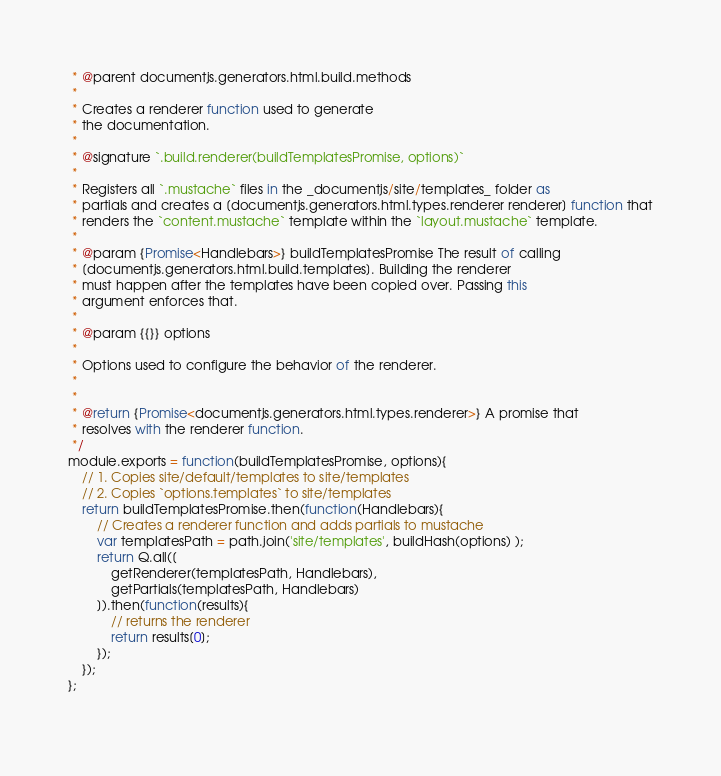<code> <loc_0><loc_0><loc_500><loc_500><_JavaScript_> * @parent documentjs.generators.html.build.methods
 * 
 * Creates a renderer function used to generate
 * the documentation.
 * 
 * @signature `.build.renderer(buildTemplatesPromise, options)`
 * 
 * Registers all `.mustache` files in the _documentjs/site/templates_ folder as 
 * partials and creates a [documentjs.generators.html.types.renderer renderer] function that
 * renders the `content.mustache` template within the `layout.mustache` template. 
 * 
 * @param {Promise<Handlebars>} buildTemplatesPromise The result of calling 
 * [documentjs.generators.html.build.templates]. Building the renderer
 * must happen after the templates have been copied over. Passing this 
 * argument enforces that.
 * 
 * @param {{}} options
 * 
 * Options used to configure the behavior of the renderer.
 * 
 * 
 * @return {Promise<documentjs.generators.html.types.renderer>} A promise that
 * resolves with the renderer function.
 */
module.exports = function(buildTemplatesPromise, options){
	// 1. Copies site/default/templates to site/templates
	// 2. Copies `options.templates` to site/templates
	return buildTemplatesPromise.then(function(Handlebars){
		// Creates a renderer function and adds partials to mustache
		var templatesPath = path.join('site/templates', buildHash(options) );
		return Q.all([
			getRenderer(templatesPath, Handlebars),
			getPartials(templatesPath, Handlebars)
		]).then(function(results){
			// returns the renderer
			return results[0];
		});
	});
};
	</code> 